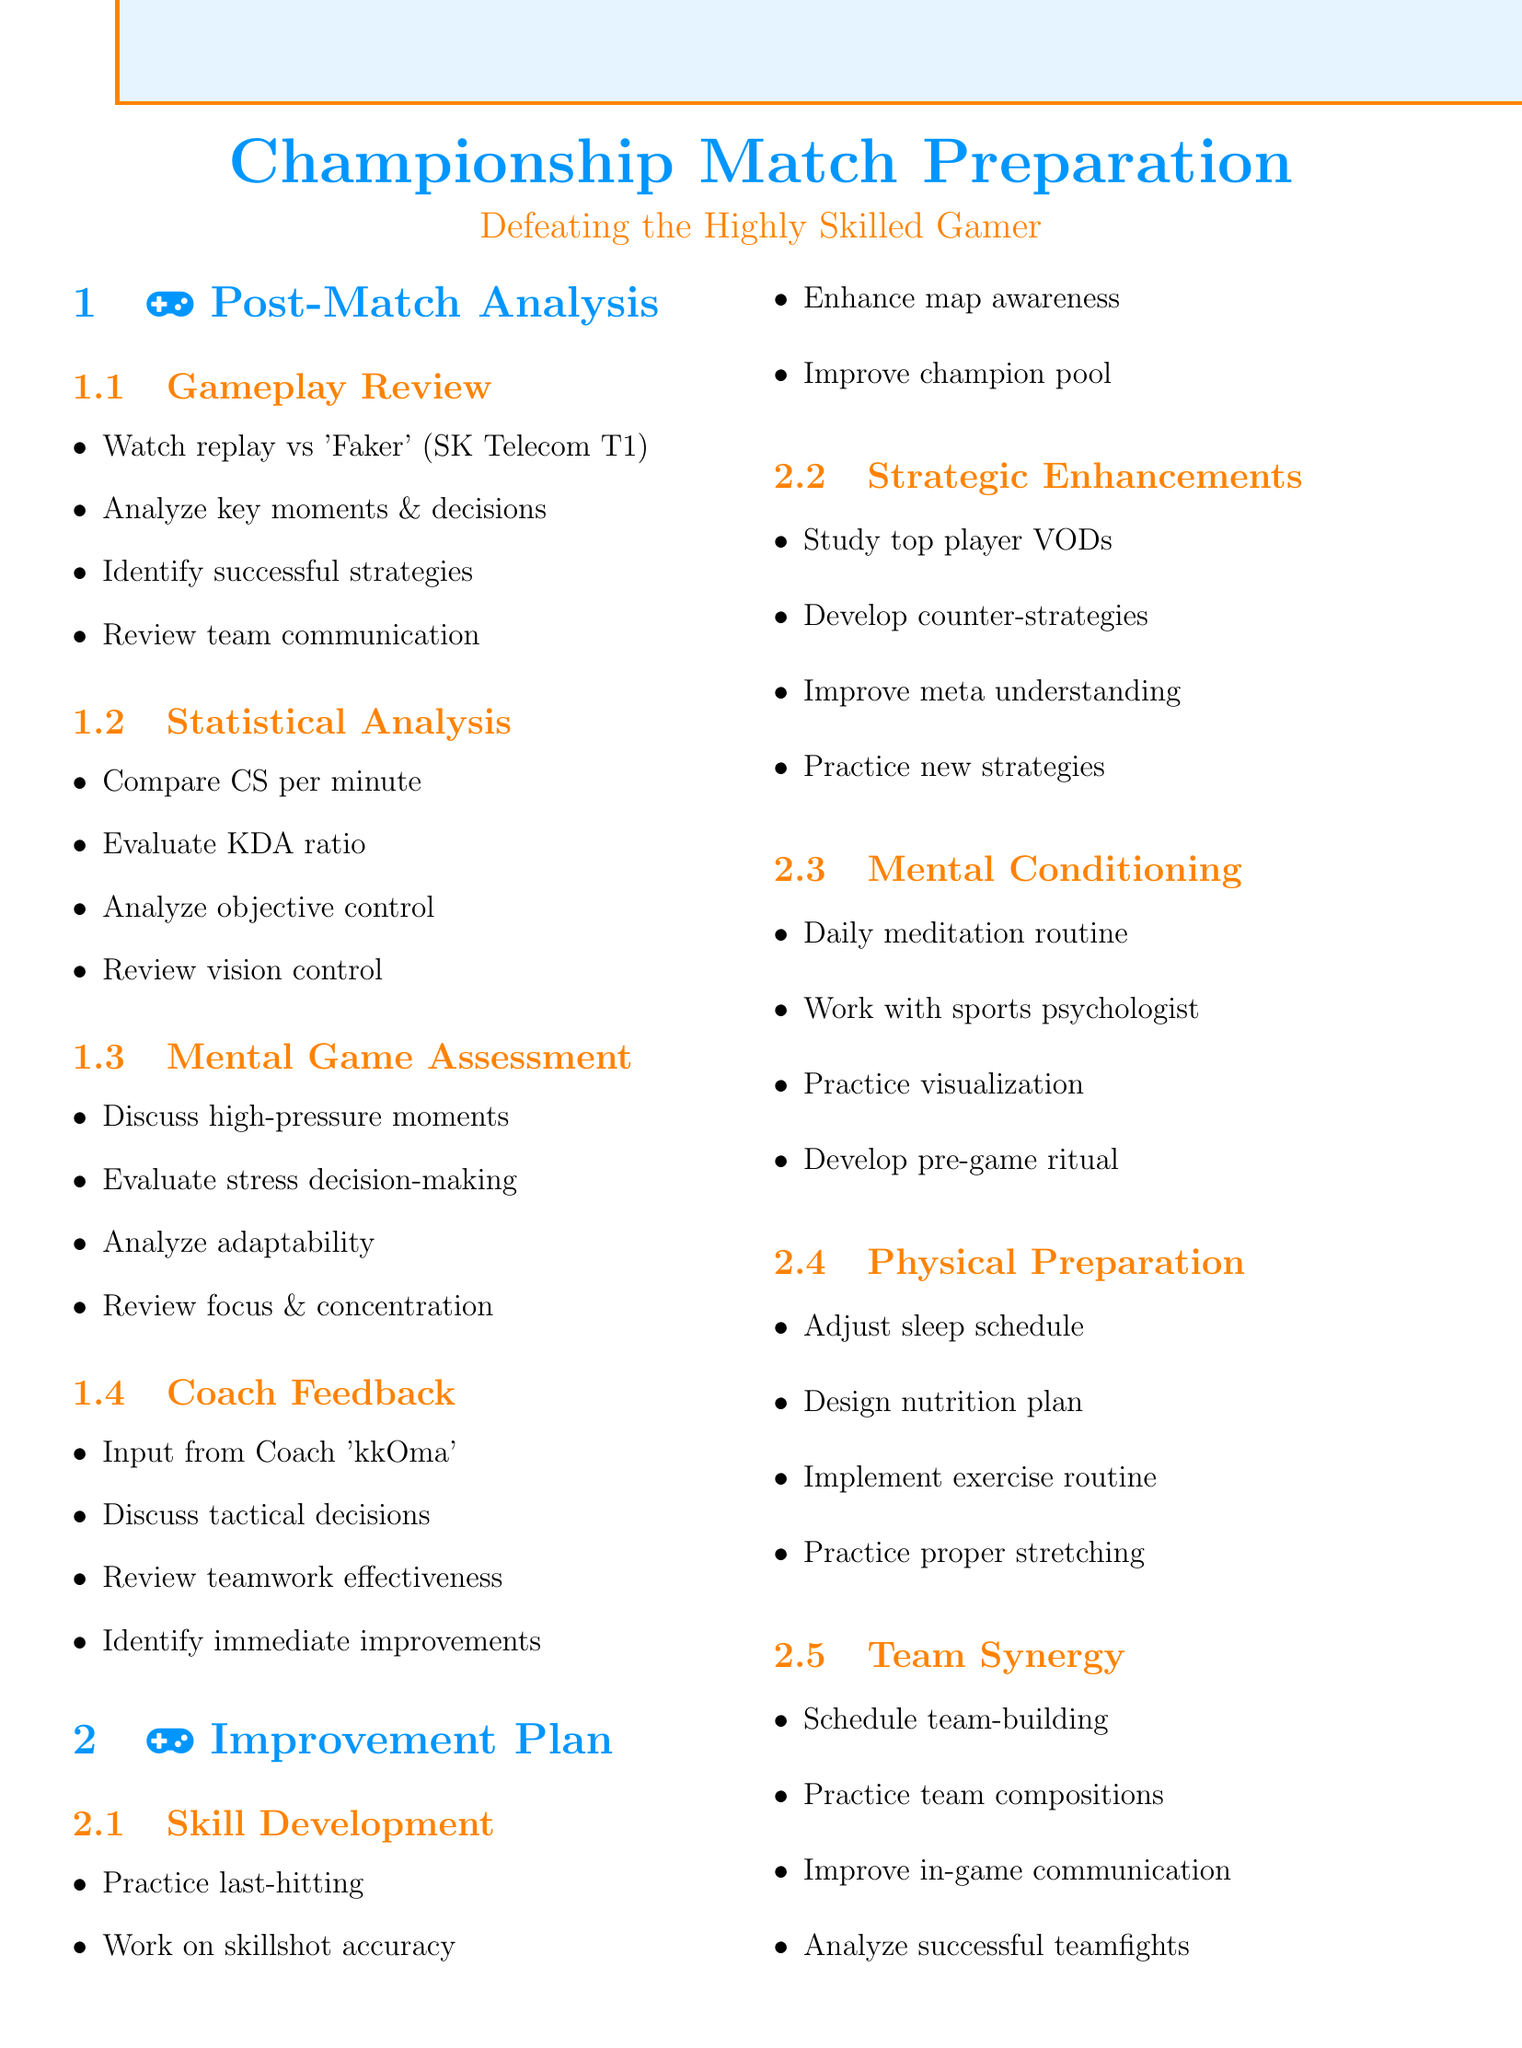What match was reviewed in the gameplay analysis? The document states that the match reviewed in the gameplay analysis was against 'Faker' from SK Telecom T1.
Answer: 'Faker' from SK Telecom T1 What aspect of gameplay does the statistical analysis focus on? The statistical analysis focuses on several aspects including KDA ratio, objective control, and vision control as detailed in the document.
Answer: KDA ratio Who provided feedback on overall performance? The coach's feedback on overall performance was provided by Coach 'kkOma'.
Answer: Coach 'kkOma' What is one method suggested for skill development? The document suggests practicing last-hitting in custom games as a method for skill development.
Answer: Last-hitting Which area involves working with Dr. Lenz? The mental conditioning area of the improvement plan involves working with sports psychologist Dr. Lenz on stress management.
Answer: Mental conditioning How many areas are listed under the improvement plan? The improvement plan consists of five areas as outlined in the document.
Answer: Five areas What activity is recommended to improve team synergy? Scheduling additional team-building activities is recommended to improve team synergy.
Answer: Team-building activities What is one focus of the mental game assessment? Discussing emotional state during high-pressure moments is one focus of the mental game assessment.
Answer: Emotional state during high-pressure moments 